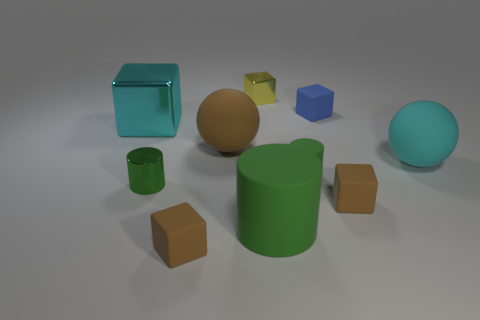Subtract all green cylinders. How many were subtracted if there are1green cylinders left? 2 Subtract all matte cylinders. How many cylinders are left? 1 Subtract all cyan balls. How many balls are left? 1 Subtract all balls. How many objects are left? 8 Subtract 1 cylinders. How many cylinders are left? 2 Subtract all green balls. How many brown cubes are left? 2 Add 2 small things. How many small things are left? 8 Add 6 brown balls. How many brown balls exist? 7 Subtract 1 cyan blocks. How many objects are left? 9 Subtract all brown cylinders. Subtract all green blocks. How many cylinders are left? 3 